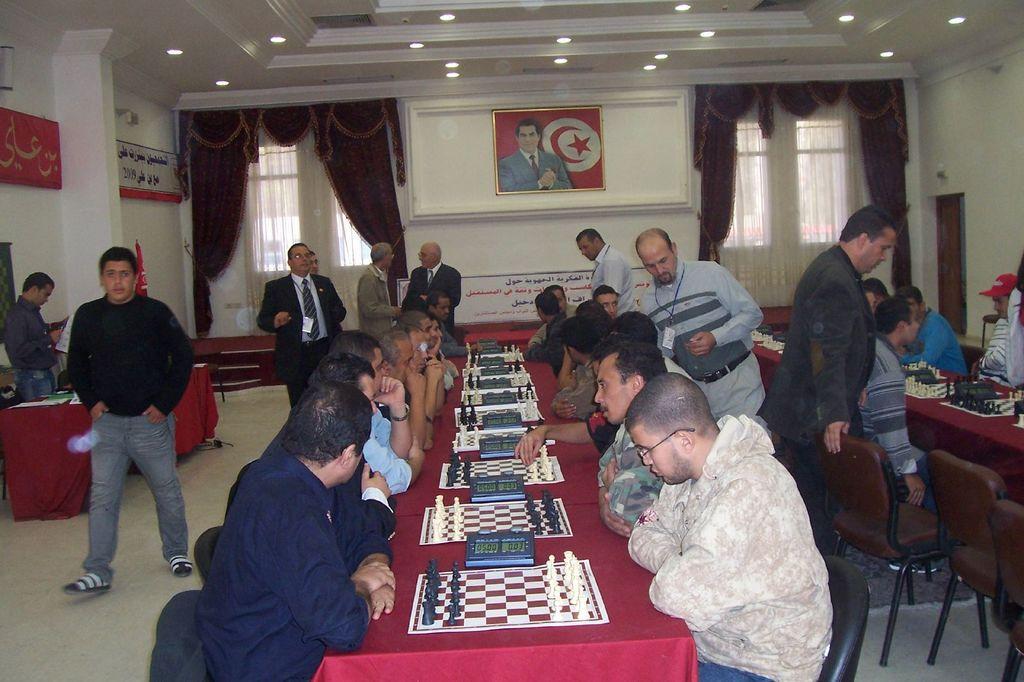Describe this image in one or two sentences. here in this picture we can see the people sitting in the chairs and playing chess board which are in front of them on the table, here we can also see some people are walking around them, here we can see a frame on the wall. 